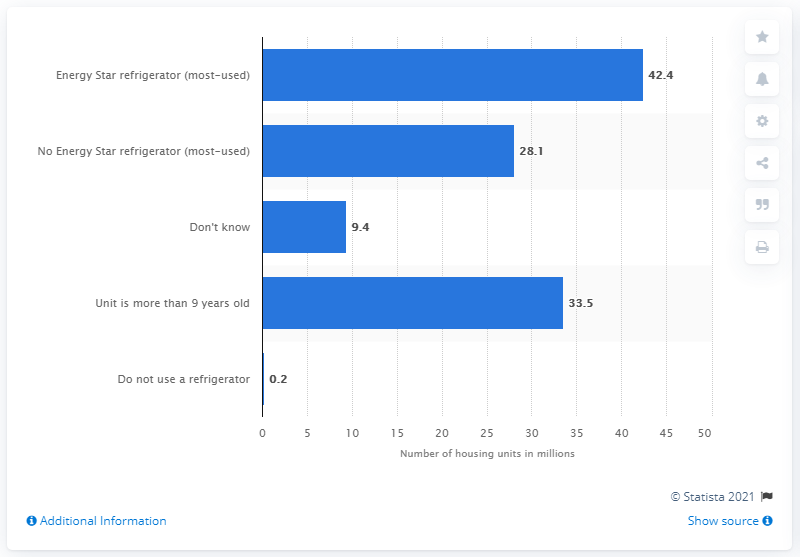Draw attention to some important aspects in this diagram. In 2020, 28.1% of housing units in the United States used an Energy Star qualified refrigerator. 